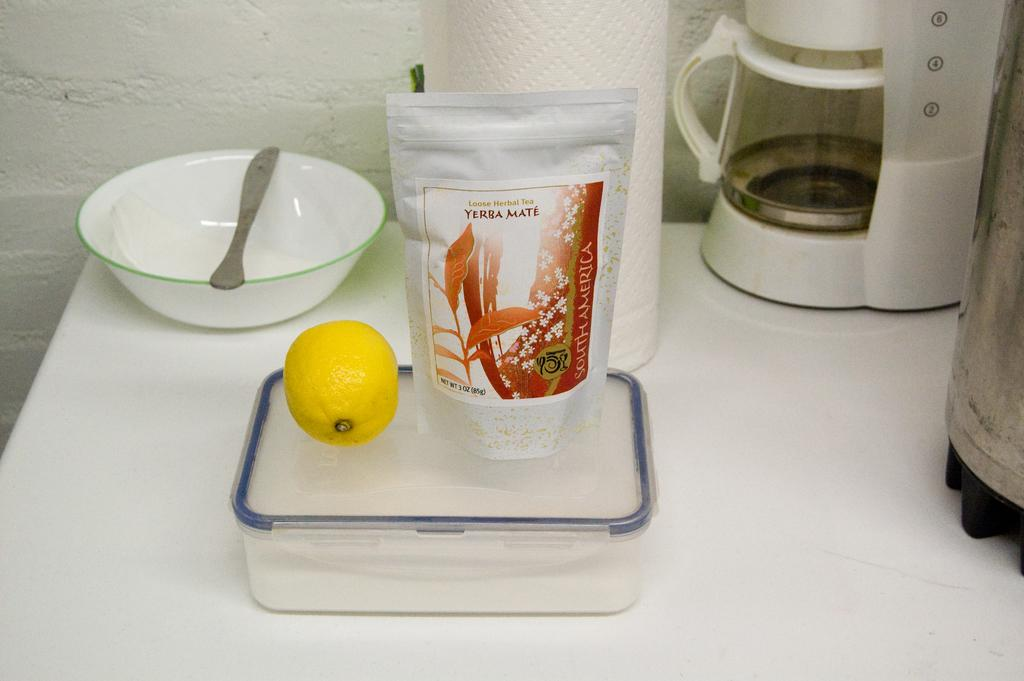<image>
Describe the image concisely. A plastic bag of loose herbal tea next to a lemon. 